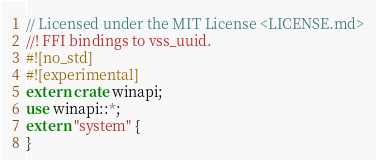Convert code to text. <code><loc_0><loc_0><loc_500><loc_500><_Rust_>// Licensed under the MIT License <LICENSE.md>
//! FFI bindings to vss_uuid.
#![no_std]
#![experimental]
extern crate winapi;
use winapi::*;
extern "system" {
}
</code> 